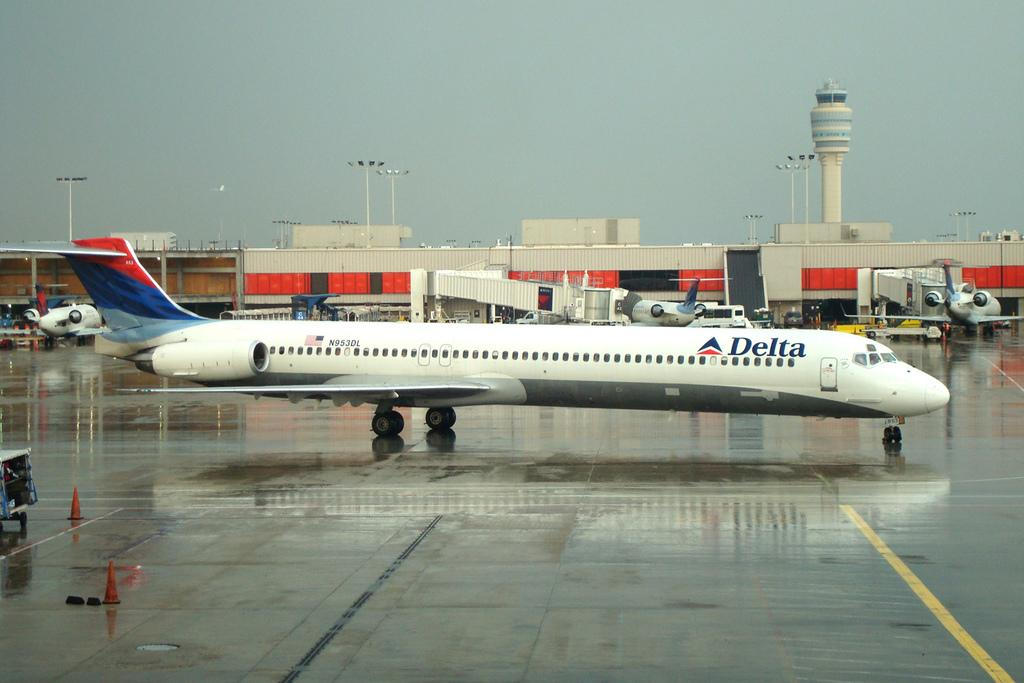What type of transportation can be seen in the image? There are airplanes and vehicles in the image. What objects are present on the road in the image? Traffic cones are present on the road in the image. What type of structure is visible in the image? There is a building and a tower in the image. What is visible in the background of the image? The sky is visible in the background of the image. What other objects can be seen in the image? Poles and lights are visible in the image. What color is the polish used on the letters in the image? There are no letters or polish present in the image. What type of color can be seen on the airplanes in the image? The provided facts do not mention the color of the airplanes in the image. 